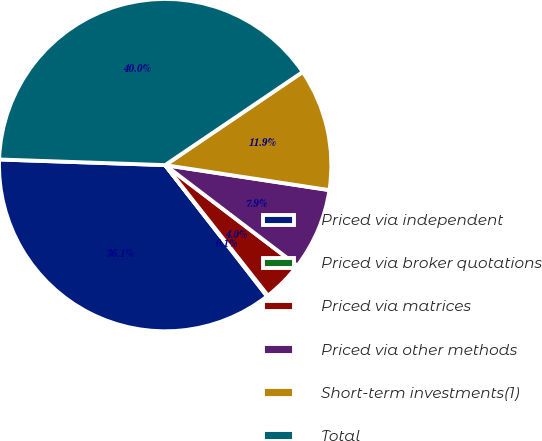Convert chart. <chart><loc_0><loc_0><loc_500><loc_500><pie_chart><fcel>Priced via independent<fcel>Priced via broker quotations<fcel>Priced via matrices<fcel>Priced via other methods<fcel>Short-term investments(1)<fcel>Total<nl><fcel>36.06%<fcel>0.1%<fcel>4.03%<fcel>7.95%<fcel>11.88%<fcel>39.99%<nl></chart> 